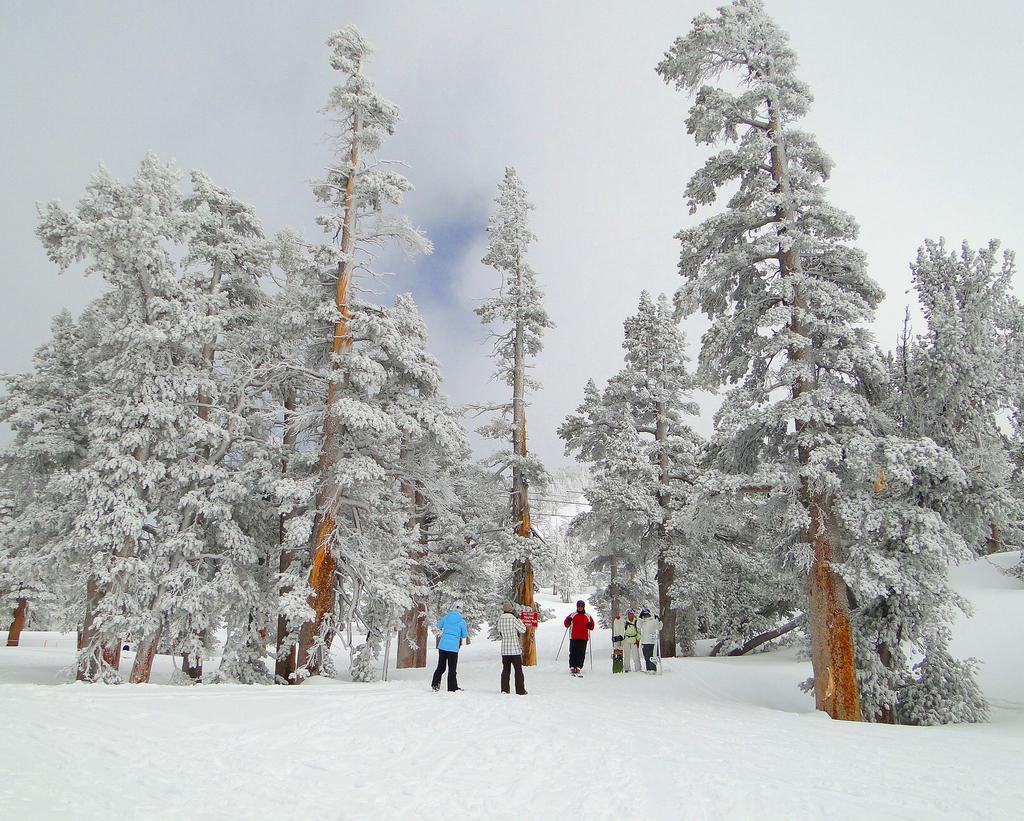In one or two sentences, can you explain what this image depicts? Here we can see few persons and snow. There are trees covered with the snow. In the background there is sky. 